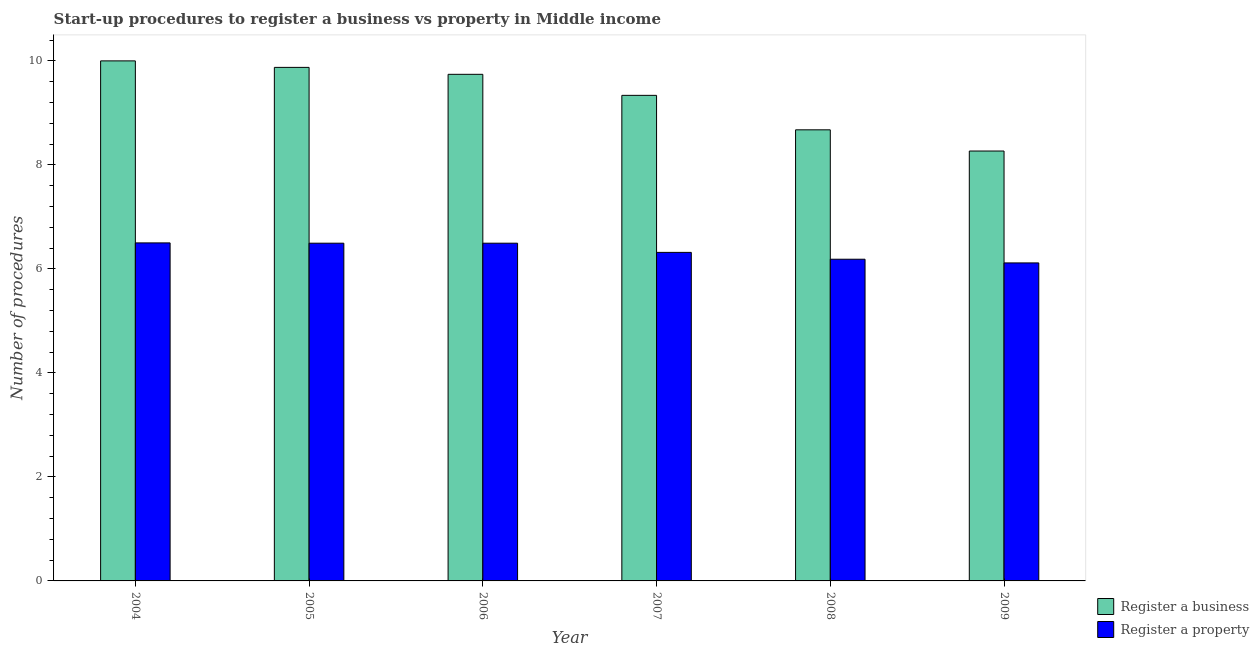How many different coloured bars are there?
Ensure brevity in your answer.  2. Are the number of bars on each tick of the X-axis equal?
Your answer should be very brief. Yes. How many bars are there on the 6th tick from the right?
Offer a terse response. 2. What is the label of the 6th group of bars from the left?
Provide a short and direct response. 2009. In how many cases, is the number of bars for a given year not equal to the number of legend labels?
Your response must be concise. 0. What is the number of procedures to register a business in 2009?
Keep it short and to the point. 8.27. Across all years, what is the maximum number of procedures to register a property?
Ensure brevity in your answer.  6.5. Across all years, what is the minimum number of procedures to register a business?
Offer a very short reply. 8.27. In which year was the number of procedures to register a property minimum?
Give a very brief answer. 2009. What is the total number of procedures to register a property in the graph?
Keep it short and to the point. 38.11. What is the difference between the number of procedures to register a property in 2007 and that in 2009?
Your answer should be compact. 0.2. What is the difference between the number of procedures to register a business in 2005 and the number of procedures to register a property in 2006?
Provide a succinct answer. 0.13. What is the average number of procedures to register a property per year?
Offer a very short reply. 6.35. What is the ratio of the number of procedures to register a property in 2006 to that in 2007?
Offer a very short reply. 1.03. Is the number of procedures to register a property in 2004 less than that in 2005?
Ensure brevity in your answer.  No. What is the difference between the highest and the lowest number of procedures to register a property?
Offer a terse response. 0.39. In how many years, is the number of procedures to register a business greater than the average number of procedures to register a business taken over all years?
Keep it short and to the point. 4. Is the sum of the number of procedures to register a property in 2007 and 2009 greater than the maximum number of procedures to register a business across all years?
Your answer should be compact. Yes. What does the 1st bar from the left in 2009 represents?
Your answer should be very brief. Register a business. What does the 1st bar from the right in 2008 represents?
Ensure brevity in your answer.  Register a property. Are all the bars in the graph horizontal?
Make the answer very short. No. Does the graph contain any zero values?
Your answer should be very brief. No. Does the graph contain grids?
Offer a terse response. No. Where does the legend appear in the graph?
Provide a succinct answer. Bottom right. How many legend labels are there?
Provide a short and direct response. 2. What is the title of the graph?
Provide a short and direct response. Start-up procedures to register a business vs property in Middle income. Does "Private creditors" appear as one of the legend labels in the graph?
Make the answer very short. No. What is the label or title of the X-axis?
Ensure brevity in your answer.  Year. What is the label or title of the Y-axis?
Keep it short and to the point. Number of procedures. What is the Number of procedures in Register a business in 2004?
Ensure brevity in your answer.  10. What is the Number of procedures in Register a property in 2004?
Provide a succinct answer. 6.5. What is the Number of procedures in Register a business in 2005?
Your answer should be very brief. 9.88. What is the Number of procedures in Register a property in 2005?
Ensure brevity in your answer.  6.49. What is the Number of procedures of Register a business in 2006?
Offer a terse response. 9.74. What is the Number of procedures in Register a property in 2006?
Make the answer very short. 6.49. What is the Number of procedures of Register a business in 2007?
Keep it short and to the point. 9.34. What is the Number of procedures of Register a property in 2007?
Provide a short and direct response. 6.32. What is the Number of procedures of Register a business in 2008?
Provide a short and direct response. 8.67. What is the Number of procedures of Register a property in 2008?
Give a very brief answer. 6.19. What is the Number of procedures of Register a business in 2009?
Offer a terse response. 8.27. What is the Number of procedures of Register a property in 2009?
Keep it short and to the point. 6.11. Across all years, what is the minimum Number of procedures of Register a business?
Offer a terse response. 8.27. Across all years, what is the minimum Number of procedures in Register a property?
Make the answer very short. 6.11. What is the total Number of procedures of Register a business in the graph?
Keep it short and to the point. 55.89. What is the total Number of procedures in Register a property in the graph?
Ensure brevity in your answer.  38.11. What is the difference between the Number of procedures in Register a property in 2004 and that in 2005?
Provide a short and direct response. 0.01. What is the difference between the Number of procedures in Register a business in 2004 and that in 2006?
Provide a succinct answer. 0.26. What is the difference between the Number of procedures in Register a property in 2004 and that in 2006?
Give a very brief answer. 0.01. What is the difference between the Number of procedures in Register a business in 2004 and that in 2007?
Ensure brevity in your answer.  0.66. What is the difference between the Number of procedures in Register a property in 2004 and that in 2007?
Your answer should be compact. 0.18. What is the difference between the Number of procedures in Register a business in 2004 and that in 2008?
Make the answer very short. 1.33. What is the difference between the Number of procedures in Register a property in 2004 and that in 2008?
Offer a very short reply. 0.31. What is the difference between the Number of procedures in Register a business in 2004 and that in 2009?
Your response must be concise. 1.73. What is the difference between the Number of procedures in Register a property in 2004 and that in 2009?
Keep it short and to the point. 0.39. What is the difference between the Number of procedures of Register a business in 2005 and that in 2006?
Ensure brevity in your answer.  0.13. What is the difference between the Number of procedures in Register a property in 2005 and that in 2006?
Give a very brief answer. 0. What is the difference between the Number of procedures in Register a business in 2005 and that in 2007?
Your response must be concise. 0.54. What is the difference between the Number of procedures in Register a property in 2005 and that in 2007?
Your answer should be very brief. 0.18. What is the difference between the Number of procedures of Register a business in 2005 and that in 2008?
Your answer should be compact. 1.2. What is the difference between the Number of procedures of Register a property in 2005 and that in 2008?
Provide a succinct answer. 0.31. What is the difference between the Number of procedures of Register a business in 2005 and that in 2009?
Make the answer very short. 1.61. What is the difference between the Number of procedures in Register a property in 2005 and that in 2009?
Provide a short and direct response. 0.38. What is the difference between the Number of procedures of Register a business in 2006 and that in 2007?
Keep it short and to the point. 0.4. What is the difference between the Number of procedures of Register a property in 2006 and that in 2007?
Offer a very short reply. 0.18. What is the difference between the Number of procedures of Register a business in 2006 and that in 2008?
Ensure brevity in your answer.  1.07. What is the difference between the Number of procedures of Register a property in 2006 and that in 2008?
Provide a short and direct response. 0.31. What is the difference between the Number of procedures in Register a business in 2006 and that in 2009?
Keep it short and to the point. 1.47. What is the difference between the Number of procedures in Register a property in 2006 and that in 2009?
Your answer should be very brief. 0.38. What is the difference between the Number of procedures of Register a business in 2007 and that in 2008?
Provide a succinct answer. 0.66. What is the difference between the Number of procedures of Register a property in 2007 and that in 2008?
Provide a short and direct response. 0.13. What is the difference between the Number of procedures of Register a business in 2007 and that in 2009?
Offer a terse response. 1.07. What is the difference between the Number of procedures of Register a property in 2007 and that in 2009?
Provide a short and direct response. 0.2. What is the difference between the Number of procedures of Register a business in 2008 and that in 2009?
Provide a short and direct response. 0.41. What is the difference between the Number of procedures of Register a property in 2008 and that in 2009?
Your answer should be compact. 0.07. What is the difference between the Number of procedures of Register a business in 2004 and the Number of procedures of Register a property in 2005?
Your response must be concise. 3.51. What is the difference between the Number of procedures in Register a business in 2004 and the Number of procedures in Register a property in 2006?
Make the answer very short. 3.51. What is the difference between the Number of procedures in Register a business in 2004 and the Number of procedures in Register a property in 2007?
Make the answer very short. 3.68. What is the difference between the Number of procedures of Register a business in 2004 and the Number of procedures of Register a property in 2008?
Your answer should be very brief. 3.81. What is the difference between the Number of procedures in Register a business in 2004 and the Number of procedures in Register a property in 2009?
Your answer should be very brief. 3.89. What is the difference between the Number of procedures in Register a business in 2005 and the Number of procedures in Register a property in 2006?
Give a very brief answer. 3.38. What is the difference between the Number of procedures in Register a business in 2005 and the Number of procedures in Register a property in 2007?
Keep it short and to the point. 3.56. What is the difference between the Number of procedures in Register a business in 2005 and the Number of procedures in Register a property in 2008?
Keep it short and to the point. 3.69. What is the difference between the Number of procedures in Register a business in 2005 and the Number of procedures in Register a property in 2009?
Ensure brevity in your answer.  3.76. What is the difference between the Number of procedures of Register a business in 2006 and the Number of procedures of Register a property in 2007?
Provide a succinct answer. 3.42. What is the difference between the Number of procedures in Register a business in 2006 and the Number of procedures in Register a property in 2008?
Ensure brevity in your answer.  3.56. What is the difference between the Number of procedures of Register a business in 2006 and the Number of procedures of Register a property in 2009?
Offer a terse response. 3.63. What is the difference between the Number of procedures of Register a business in 2007 and the Number of procedures of Register a property in 2008?
Your answer should be compact. 3.15. What is the difference between the Number of procedures of Register a business in 2007 and the Number of procedures of Register a property in 2009?
Give a very brief answer. 3.22. What is the difference between the Number of procedures of Register a business in 2008 and the Number of procedures of Register a property in 2009?
Give a very brief answer. 2.56. What is the average Number of procedures of Register a business per year?
Make the answer very short. 9.32. What is the average Number of procedures of Register a property per year?
Provide a short and direct response. 6.35. In the year 2004, what is the difference between the Number of procedures of Register a business and Number of procedures of Register a property?
Provide a short and direct response. 3.5. In the year 2005, what is the difference between the Number of procedures in Register a business and Number of procedures in Register a property?
Keep it short and to the point. 3.38. In the year 2006, what is the difference between the Number of procedures of Register a business and Number of procedures of Register a property?
Provide a short and direct response. 3.25. In the year 2007, what is the difference between the Number of procedures of Register a business and Number of procedures of Register a property?
Give a very brief answer. 3.02. In the year 2008, what is the difference between the Number of procedures in Register a business and Number of procedures in Register a property?
Provide a short and direct response. 2.49. In the year 2009, what is the difference between the Number of procedures of Register a business and Number of procedures of Register a property?
Your response must be concise. 2.15. What is the ratio of the Number of procedures in Register a business in 2004 to that in 2005?
Your answer should be compact. 1.01. What is the ratio of the Number of procedures of Register a business in 2004 to that in 2006?
Provide a short and direct response. 1.03. What is the ratio of the Number of procedures in Register a property in 2004 to that in 2006?
Give a very brief answer. 1. What is the ratio of the Number of procedures in Register a business in 2004 to that in 2007?
Your answer should be very brief. 1.07. What is the ratio of the Number of procedures of Register a property in 2004 to that in 2007?
Provide a short and direct response. 1.03. What is the ratio of the Number of procedures in Register a business in 2004 to that in 2008?
Your answer should be very brief. 1.15. What is the ratio of the Number of procedures in Register a property in 2004 to that in 2008?
Your answer should be compact. 1.05. What is the ratio of the Number of procedures of Register a business in 2004 to that in 2009?
Offer a very short reply. 1.21. What is the ratio of the Number of procedures in Register a property in 2004 to that in 2009?
Your response must be concise. 1.06. What is the ratio of the Number of procedures in Register a business in 2005 to that in 2006?
Offer a terse response. 1.01. What is the ratio of the Number of procedures of Register a business in 2005 to that in 2007?
Your answer should be compact. 1.06. What is the ratio of the Number of procedures in Register a property in 2005 to that in 2007?
Offer a terse response. 1.03. What is the ratio of the Number of procedures of Register a business in 2005 to that in 2008?
Keep it short and to the point. 1.14. What is the ratio of the Number of procedures of Register a property in 2005 to that in 2008?
Make the answer very short. 1.05. What is the ratio of the Number of procedures of Register a business in 2005 to that in 2009?
Your response must be concise. 1.19. What is the ratio of the Number of procedures in Register a property in 2005 to that in 2009?
Ensure brevity in your answer.  1.06. What is the ratio of the Number of procedures in Register a business in 2006 to that in 2007?
Provide a short and direct response. 1.04. What is the ratio of the Number of procedures in Register a property in 2006 to that in 2007?
Keep it short and to the point. 1.03. What is the ratio of the Number of procedures of Register a business in 2006 to that in 2008?
Offer a terse response. 1.12. What is the ratio of the Number of procedures of Register a property in 2006 to that in 2008?
Provide a succinct answer. 1.05. What is the ratio of the Number of procedures of Register a business in 2006 to that in 2009?
Provide a short and direct response. 1.18. What is the ratio of the Number of procedures of Register a property in 2006 to that in 2009?
Your answer should be compact. 1.06. What is the ratio of the Number of procedures in Register a business in 2007 to that in 2008?
Your answer should be very brief. 1.08. What is the ratio of the Number of procedures of Register a property in 2007 to that in 2008?
Ensure brevity in your answer.  1.02. What is the ratio of the Number of procedures in Register a business in 2007 to that in 2009?
Your answer should be very brief. 1.13. What is the ratio of the Number of procedures in Register a property in 2007 to that in 2009?
Provide a succinct answer. 1.03. What is the ratio of the Number of procedures of Register a business in 2008 to that in 2009?
Give a very brief answer. 1.05. What is the ratio of the Number of procedures in Register a property in 2008 to that in 2009?
Your answer should be very brief. 1.01. What is the difference between the highest and the second highest Number of procedures of Register a property?
Keep it short and to the point. 0.01. What is the difference between the highest and the lowest Number of procedures in Register a business?
Provide a succinct answer. 1.73. What is the difference between the highest and the lowest Number of procedures of Register a property?
Your response must be concise. 0.39. 